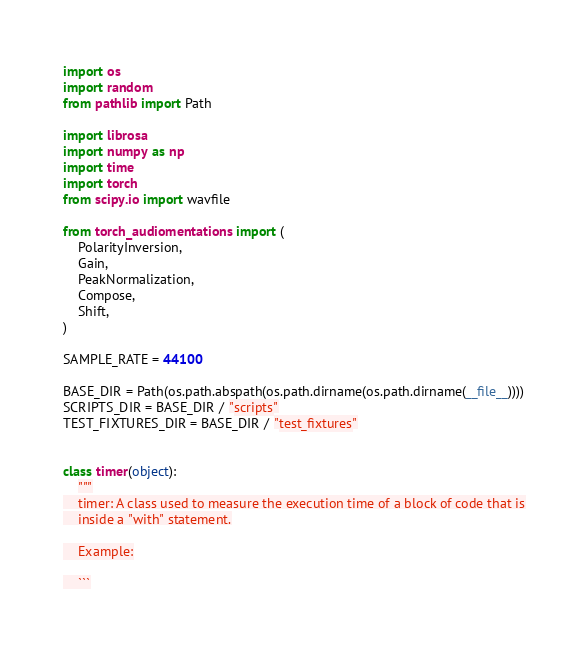<code> <loc_0><loc_0><loc_500><loc_500><_Python_>import os
import random
from pathlib import Path

import librosa
import numpy as np
import time
import torch
from scipy.io import wavfile

from torch_audiomentations import (
    PolarityInversion,
    Gain,
    PeakNormalization,
    Compose,
    Shift,
)

SAMPLE_RATE = 44100

BASE_DIR = Path(os.path.abspath(os.path.dirname(os.path.dirname(__file__))))
SCRIPTS_DIR = BASE_DIR / "scripts"
TEST_FIXTURES_DIR = BASE_DIR / "test_fixtures"


class timer(object):
    """
    timer: A class used to measure the execution time of a block of code that is
    inside a "with" statement.

    Example:

    ```</code> 